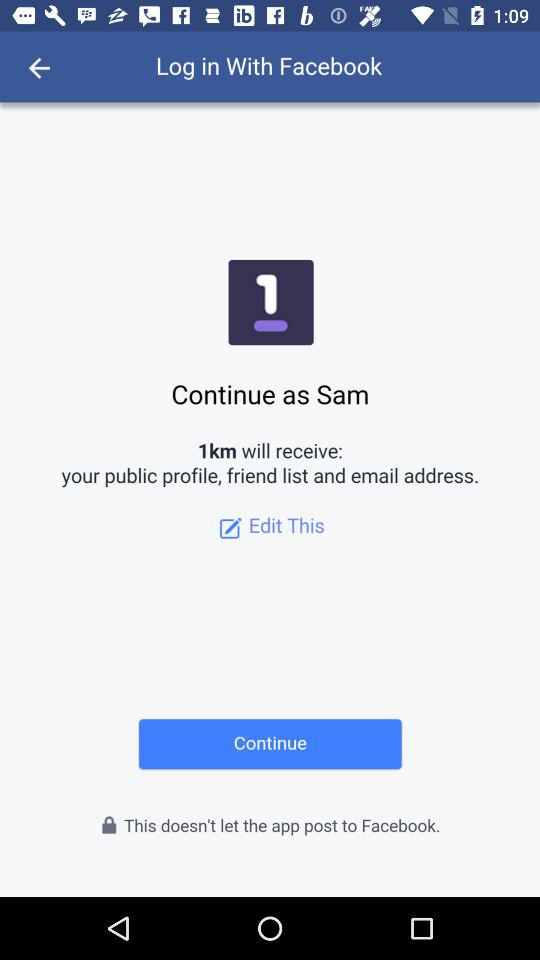What is the user name? The user name is Sam. 